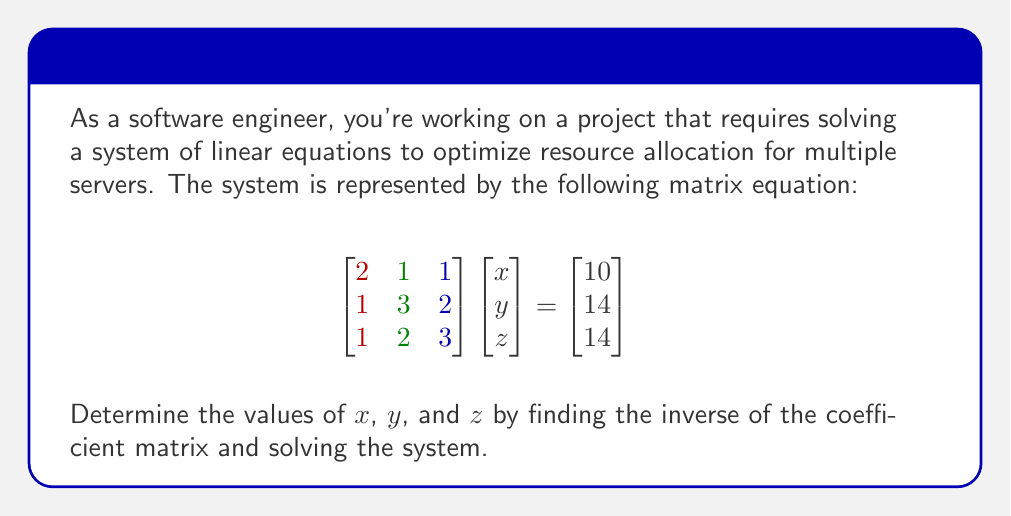Provide a solution to this math problem. To solve this system using matrix inversion, we'll follow these steps:

1) First, we need to find the inverse of the coefficient matrix A:

   $$A = \begin{bmatrix}
   2 & 1 & 1 \\
   1 & 3 & 2 \\
   1 & 2 & 3
   \end{bmatrix}$$

2) To find $A^{-1}$, we'll use the adjoint method:
   
   a) Find the determinant of A:
      $det(A) = 2(9-4) + 1(3-1) + 1(2-3) = 10 + 2 - 1 = 11$

   b) Find the adjoint of A:
      $$adj(A) = \begin{bmatrix}
      7 & -3 & -2 \\
      -3 & 5 & -1 \\
      -2 & -1 & 5
      \end{bmatrix}$$

   c) Calculate $A^{-1} = \frac{1}{det(A)} \cdot adj(A)$:
      $$A^{-1} = \frac{1}{11} \begin{bmatrix}
      7 & -3 & -2 \\
      -3 & 5 & -1 \\
      -2 & -1 & 5
      \end{bmatrix}$$

3) Now we can solve the system $AX = B$ by multiplying both sides by $A^{-1}$:
   
   $$X = A^{-1}B = \frac{1}{11} \begin{bmatrix}
   7 & -3 & -2 \\
   -3 & 5 & -1 \\
   -2 & -1 & 5
   \end{bmatrix}
   \begin{bmatrix}
   10 \\
   14 \\
   14
   \end{bmatrix}$$

4) Performing the matrix multiplication:
   
   $$X = \frac{1}{11} \begin{bmatrix}
   7(10) + (-3)(14) + (-2)(14) \\
   (-3)(10) + 5(14) + (-1)(14) \\
   (-2)(10) + (-1)(14) + 5(14)
   \end{bmatrix}
   = \frac{1}{11} \begin{bmatrix}
   70 - 42 - 28 \\
   -30 + 70 - 14 \\
   -20 - 14 + 70
   \end{bmatrix}
   = \begin{bmatrix}
   0 \\
   26/11 \\
   36/11
   \end{bmatrix}$$

Therefore, $x = 0$, $y = 26/11$, and $z = 36/11$.
Answer: $x = 0$, $y = \frac{26}{11}$, $z = \frac{36}{11}$ 